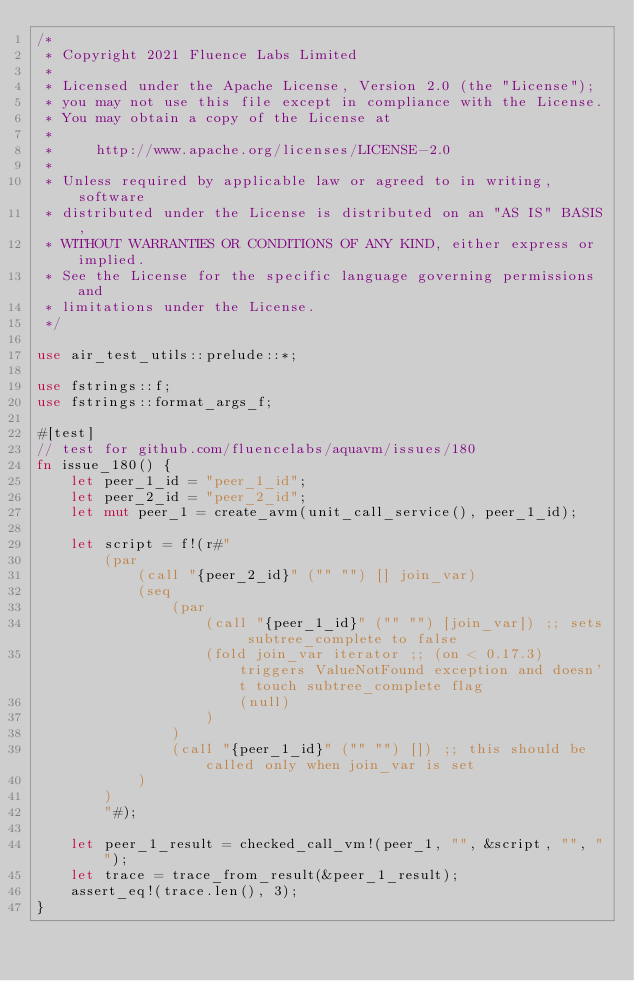Convert code to text. <code><loc_0><loc_0><loc_500><loc_500><_Rust_>/*
 * Copyright 2021 Fluence Labs Limited
 *
 * Licensed under the Apache License, Version 2.0 (the "License");
 * you may not use this file except in compliance with the License.
 * You may obtain a copy of the License at
 *
 *     http://www.apache.org/licenses/LICENSE-2.0
 *
 * Unless required by applicable law or agreed to in writing, software
 * distributed under the License is distributed on an "AS IS" BASIS,
 * WITHOUT WARRANTIES OR CONDITIONS OF ANY KIND, either express or implied.
 * See the License for the specific language governing permissions and
 * limitations under the License.
 */

use air_test_utils::prelude::*;

use fstrings::f;
use fstrings::format_args_f;

#[test]
// test for github.com/fluencelabs/aquavm/issues/180
fn issue_180() {
    let peer_1_id = "peer_1_id";
    let peer_2_id = "peer_2_id";
    let mut peer_1 = create_avm(unit_call_service(), peer_1_id);

    let script = f!(r#"
        (par
            (call "{peer_2_id}" ("" "") [] join_var)
            (seq
                (par
                    (call "{peer_1_id}" ("" "") [join_var]) ;; sets subtree_complete to false
                    (fold join_var iterator ;; (on < 0.17.3) triggers ValueNotFound exception and doesn't touch subtree_complete flag
                        (null)
                    )
                )
                (call "{peer_1_id}" ("" "") []) ;; this should be called only when join_var is set
            )
        )
        "#);

    let peer_1_result = checked_call_vm!(peer_1, "", &script, "", "");
    let trace = trace_from_result(&peer_1_result);
    assert_eq!(trace.len(), 3);
}
</code> 